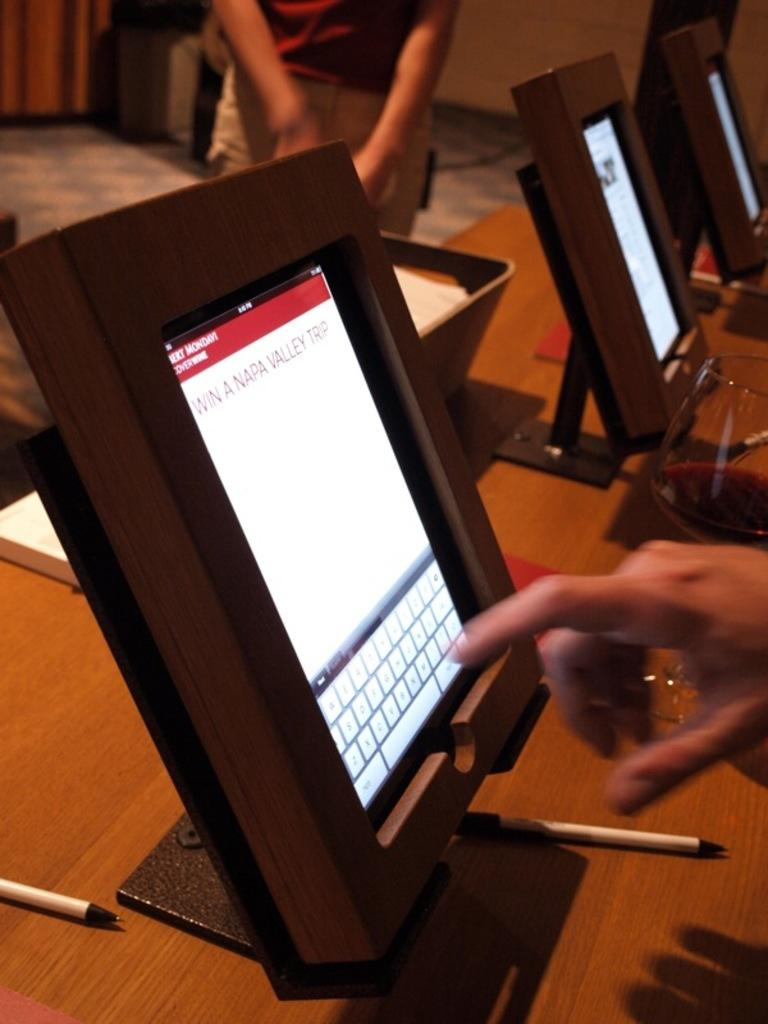What type of electronic devices are in the image? There are monitors in the image. What writing instruments are visible in the image? There are pens in the image. What type of container is in the image? There is a glass in the image. Where are the objects placed in the image? The objects are placed on a table. Whose hand is visible in the image? A person's hand is visible in the image. Can you describe the other person in the image? There is another person standing in the background of the image. What type of seed is being used to attract the person in the image? There is no seed present in the image, nor is there any indication of an attraction being used to draw the person's attention. 